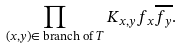<formula> <loc_0><loc_0><loc_500><loc_500>\prod _ { ( x , y ) \in \text { branch of } T } K _ { x , y } f _ { x } \overline { f _ { y } } .</formula> 